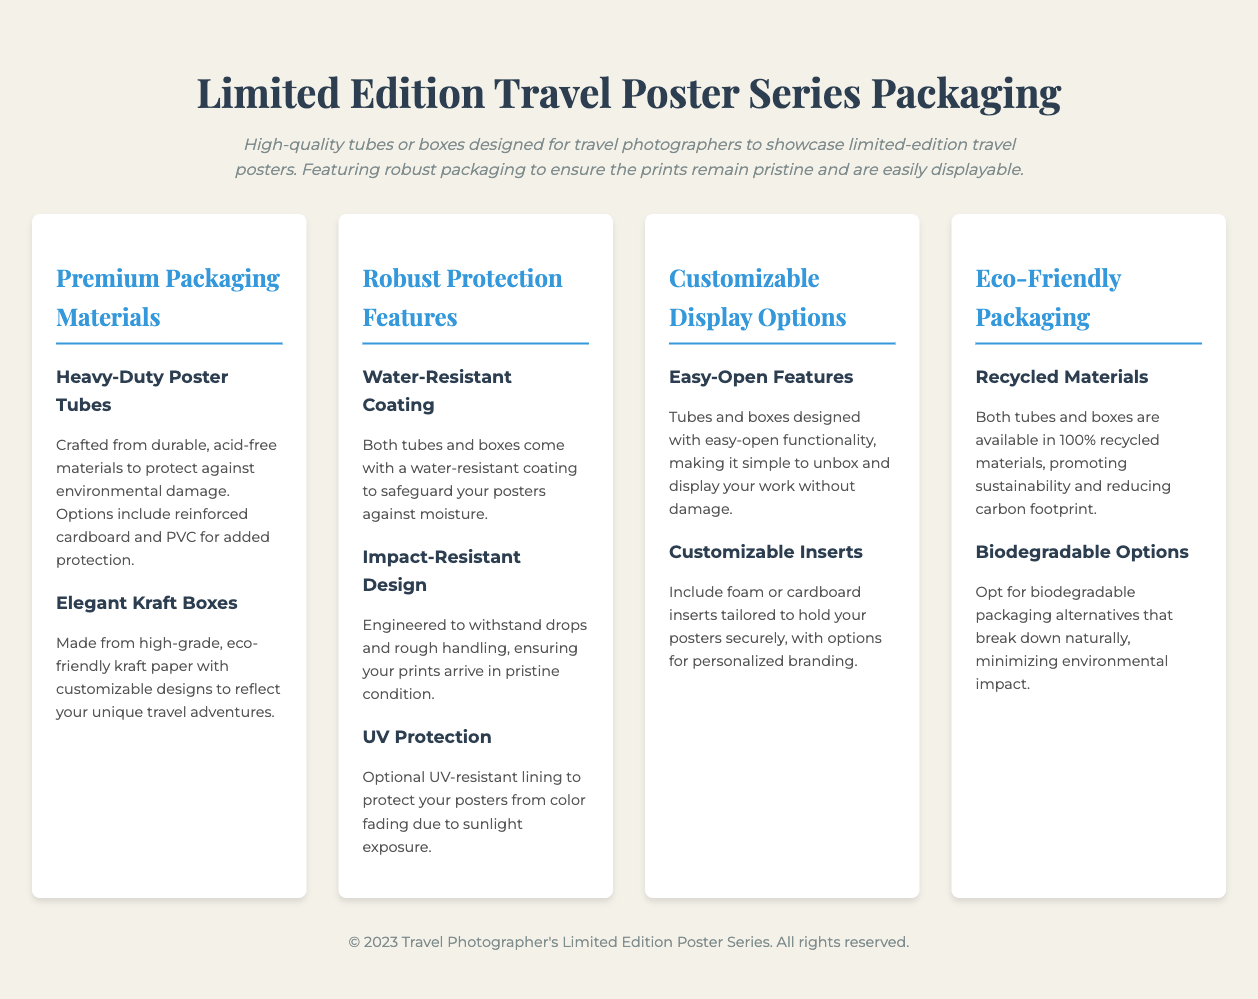What is the focus of the limited-edition travel poster packaging? The focus of the packaging is to ensure the prints remain pristine and are easily displayable.
Answer: prints remain pristine and are easily displayable What type of material are the heavy-duty poster tubes made from? The heavy-duty poster tubes are crafted from durable, acid-free materials.
Answer: durable, acid-free materials What feature protects the packaging against moisture? The tubes and boxes come with a water-resistant coating which safeguards the posters.
Answer: water-resistant coating What options are available for packaging materials? Options include reinforced cardboard and PVC for added protection.
Answer: reinforced cardboard and PVC Which aspect minimizes environmental impact? The use of 100% recycled materials promotes sustainability.
Answer: 100% recycled materials What feature ensures the packaging is easy to open? The packaging is designed with easy-open functionality.
Answer: easy-open functionality How are the packaging inserts tailored? The inserts are tailored to hold the posters securely, with options for personalized branding.
Answer: tailored to hold your posters securely What protects posters from color fading? The optional UV-resistant lining protects posters from color fading due to sunlight exposure.
Answer: UV-resistant lining 